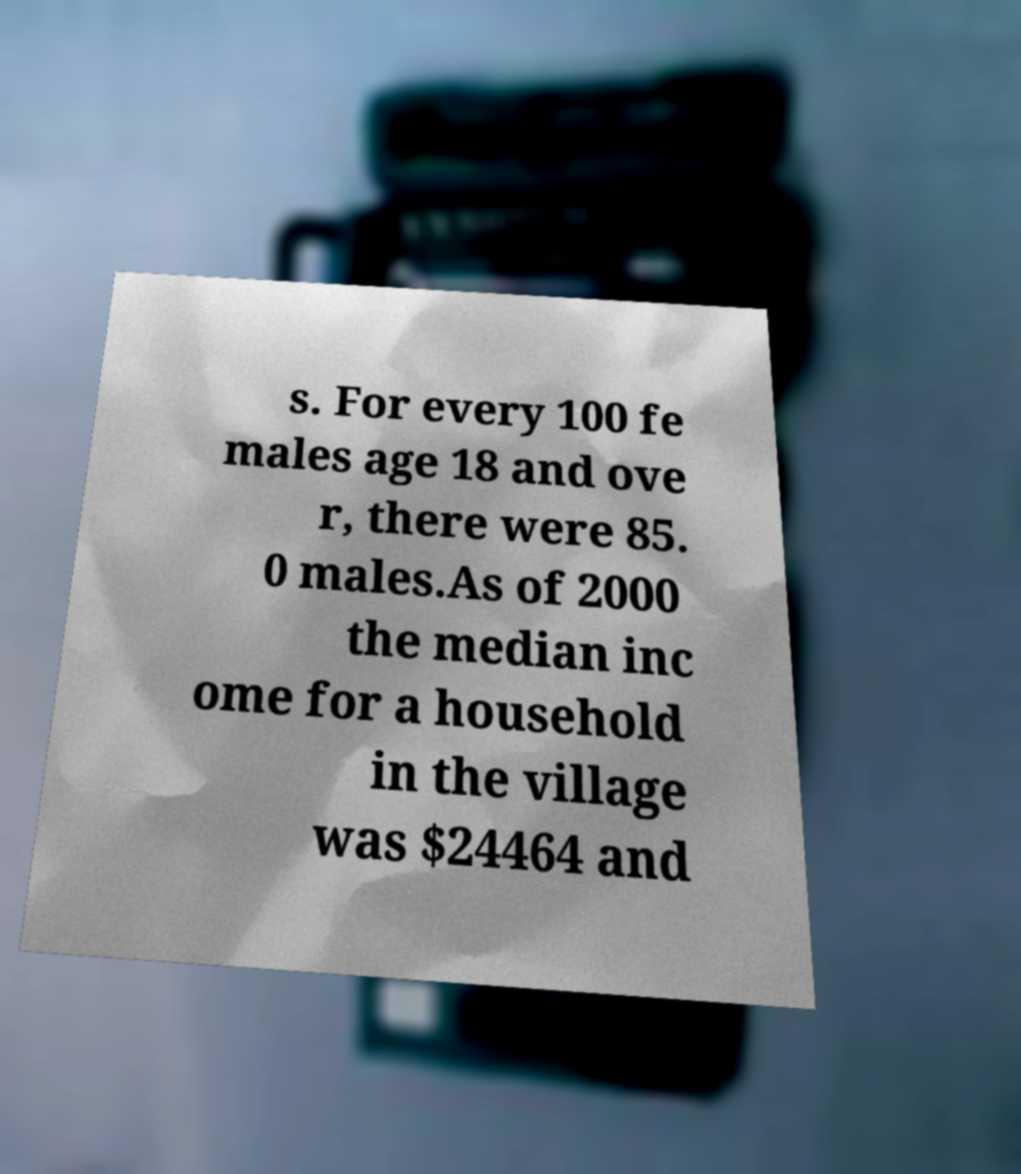There's text embedded in this image that I need extracted. Can you transcribe it verbatim? s. For every 100 fe males age 18 and ove r, there were 85. 0 males.As of 2000 the median inc ome for a household in the village was $24464 and 